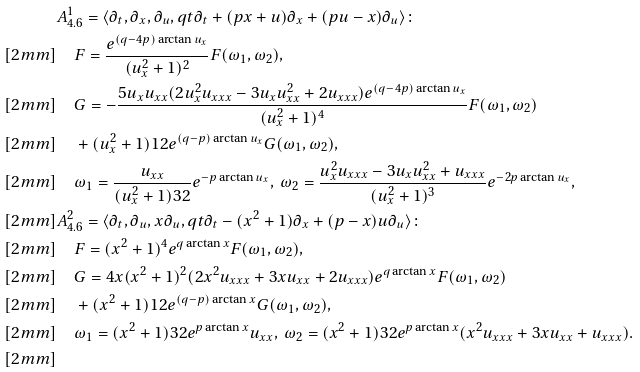Convert formula to latex. <formula><loc_0><loc_0><loc_500><loc_500>& A ^ { 1 } _ { 4 . 6 } = \langle \partial _ { t } , \partial _ { x } , \partial _ { u } , q t \partial _ { t } + ( p x + u ) \partial _ { x } + ( p u - x ) \partial _ { u } \rangle \colon \\ [ 2 m m ] & \quad F = \frac { e ^ { ( q - 4 p ) \arctan { u _ { x } } } } { ( u _ { x } ^ { 2 } + 1 ) ^ { 2 } } F ( \omega _ { 1 } , \omega _ { 2 } ) , \\ [ 2 m m ] & \quad G = - \frac { 5 u _ { x } u _ { x x } ( 2 u _ { x } ^ { 2 } u _ { x x x } - 3 u _ { x } u _ { x x } ^ { 2 } + 2 u _ { x x x } ) e ^ { ( q - 4 p ) \arctan { u _ { x } } } } { ( u _ { x } ^ { 2 } + 1 ) ^ { 4 } } F ( \omega _ { 1 } , \omega _ { 2 } ) \\ [ 2 m m ] & \quad + ( u _ { x } ^ { 2 } + 1 ) ^ { } { 1 } 2 e ^ { ( q - p ) \arctan { u _ { x } } } G ( \omega _ { 1 } , \omega _ { 2 } ) , \\ [ 2 m m ] & \quad \omega _ { 1 } = \frac { u _ { x x } } { ( u _ { x } ^ { 2 } + 1 ) ^ { } { 3 } 2 } e ^ { - p \arctan { u _ { x } } } , \ \omega _ { 2 } = \frac { u _ { x } ^ { 2 } u _ { x x x } - 3 u _ { x } u _ { x x } ^ { 2 } + u _ { x x x } } { ( u _ { x } ^ { 2 } + 1 ) ^ { 3 } } e ^ { - 2 p \arctan { u _ { x } } } , \\ [ 2 m m ] & A ^ { 2 } _ { 4 . 6 } = \langle \partial _ { t } , \partial _ { u } , x \partial _ { u } , q t \partial _ { t } - ( x ^ { 2 } + 1 ) \partial _ { x } + ( p - x ) u \partial _ { u } \rangle \colon \\ [ 2 m m ] & \quad F = ( x ^ { 2 } + 1 ) ^ { 4 } e ^ { q \arctan { x } } F ( \omega _ { 1 } , \omega _ { 2 } ) , \\ [ 2 m m ] & \quad G = 4 x ( x ^ { 2 } + 1 ) ^ { 2 } ( 2 x ^ { 2 } u _ { x x x } + 3 x u _ { x x } + 2 u _ { x x x } ) e ^ { q \arctan { x } } F ( \omega _ { 1 } , \omega _ { 2 } ) \\ [ 2 m m ] & \quad + ( x ^ { 2 } + 1 ) ^ { } { 1 } 2 e ^ { ( q - p ) \arctan { x } } G ( \omega _ { 1 } , \omega _ { 2 } ) , \\ [ 2 m m ] & \quad \omega _ { 1 } = ( x ^ { 2 } + 1 ) ^ { } { 3 } 2 e ^ { p \arctan { x } } u _ { x x } , \ \omega _ { 2 } = ( x ^ { 2 } + 1 ) ^ { } { 3 } 2 e ^ { p \arctan { x } } ( x ^ { 2 } u _ { x x x } + 3 x u _ { x x } + u _ { x x x } ) . \\ [ 2 m m ]</formula> 